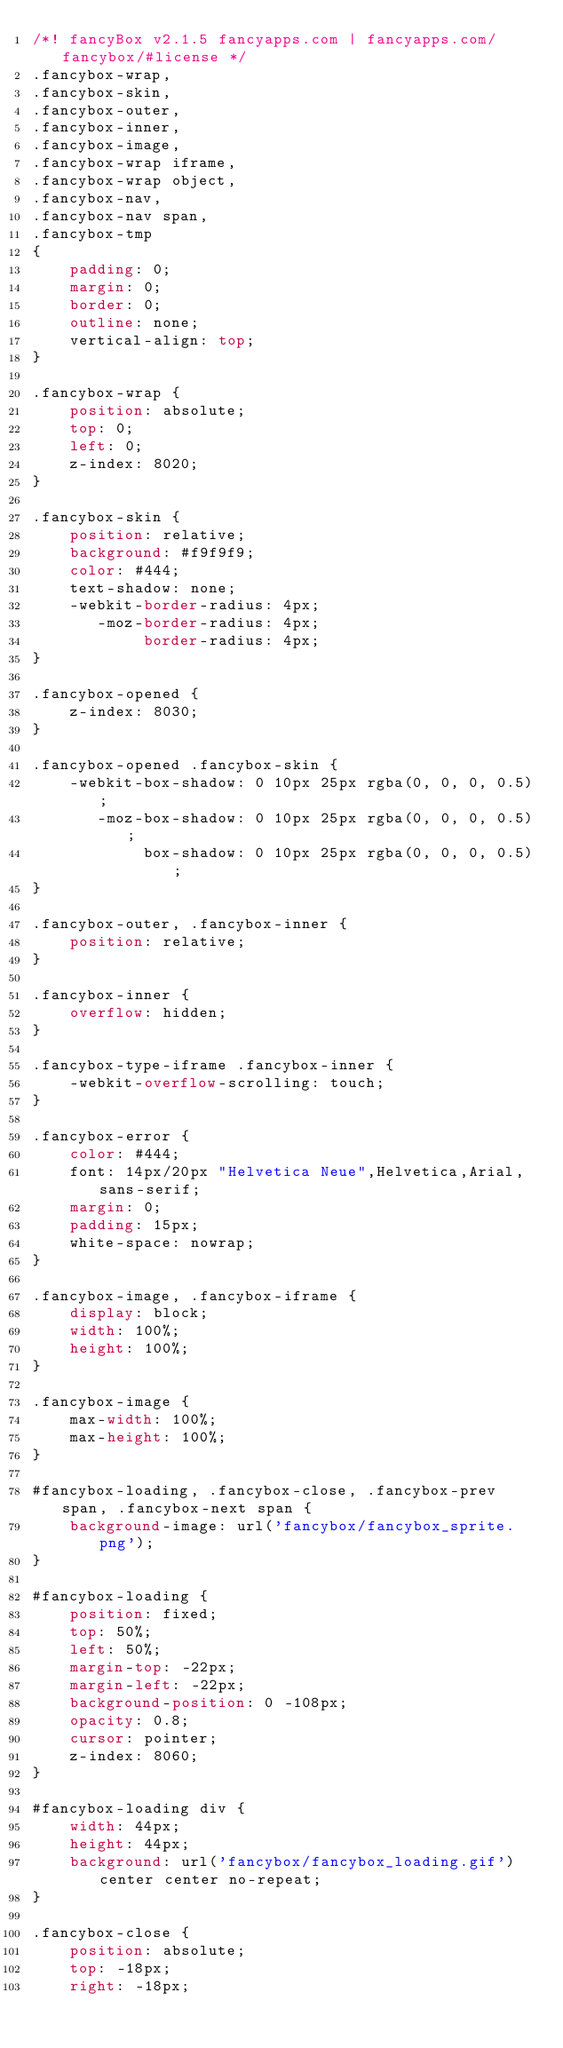<code> <loc_0><loc_0><loc_500><loc_500><_CSS_>/*! fancyBox v2.1.5 fancyapps.com | fancyapps.com/fancybox/#license */
.fancybox-wrap,
.fancybox-skin,
.fancybox-outer,
.fancybox-inner,
.fancybox-image,
.fancybox-wrap iframe,
.fancybox-wrap object,
.fancybox-nav,
.fancybox-nav span,
.fancybox-tmp
{
	padding: 0;
	margin: 0;
	border: 0;
	outline: none;
	vertical-align: top;
}

.fancybox-wrap {
	position: absolute;
	top: 0;
	left: 0;
	z-index: 8020;
}

.fancybox-skin {
	position: relative;
	background: #f9f9f9;
	color: #444;
	text-shadow: none;
	-webkit-border-radius: 4px;
	   -moz-border-radius: 4px;
	        border-radius: 4px;
}

.fancybox-opened {
	z-index: 8030;
}

.fancybox-opened .fancybox-skin {
	-webkit-box-shadow: 0 10px 25px rgba(0, 0, 0, 0.5);
	   -moz-box-shadow: 0 10px 25px rgba(0, 0, 0, 0.5);
	        box-shadow: 0 10px 25px rgba(0, 0, 0, 0.5);
}

.fancybox-outer, .fancybox-inner {
	position: relative;
}

.fancybox-inner {
	overflow: hidden;
}

.fancybox-type-iframe .fancybox-inner {
	-webkit-overflow-scrolling: touch;
}

.fancybox-error {
	color: #444;
	font: 14px/20px "Helvetica Neue",Helvetica,Arial,sans-serif;
	margin: 0;
	padding: 15px;
	white-space: nowrap;
}

.fancybox-image, .fancybox-iframe {
	display: block;
	width: 100%;
	height: 100%;
}

.fancybox-image {
	max-width: 100%;
	max-height: 100%;
}

#fancybox-loading, .fancybox-close, .fancybox-prev span, .fancybox-next span {
	background-image: url('fancybox/fancybox_sprite.png');
}

#fancybox-loading {
	position: fixed;
	top: 50%;
	left: 50%;
	margin-top: -22px;
	margin-left: -22px;
	background-position: 0 -108px;
	opacity: 0.8;
	cursor: pointer;
	z-index: 8060;
}

#fancybox-loading div {
	width: 44px;
	height: 44px;
	background: url('fancybox/fancybox_loading.gif') center center no-repeat;
}

.fancybox-close {
	position: absolute;
	top: -18px;
	right: -18px;</code> 